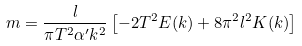Convert formula to latex. <formula><loc_0><loc_0><loc_500><loc_500>m = \frac { l } { \pi T ^ { 2 } \alpha ^ { \prime } k ^ { 2 } } \left [ - 2 T ^ { 2 } E ( k ) + 8 \pi ^ { 2 } l ^ { 2 } K ( k ) \right ]</formula> 